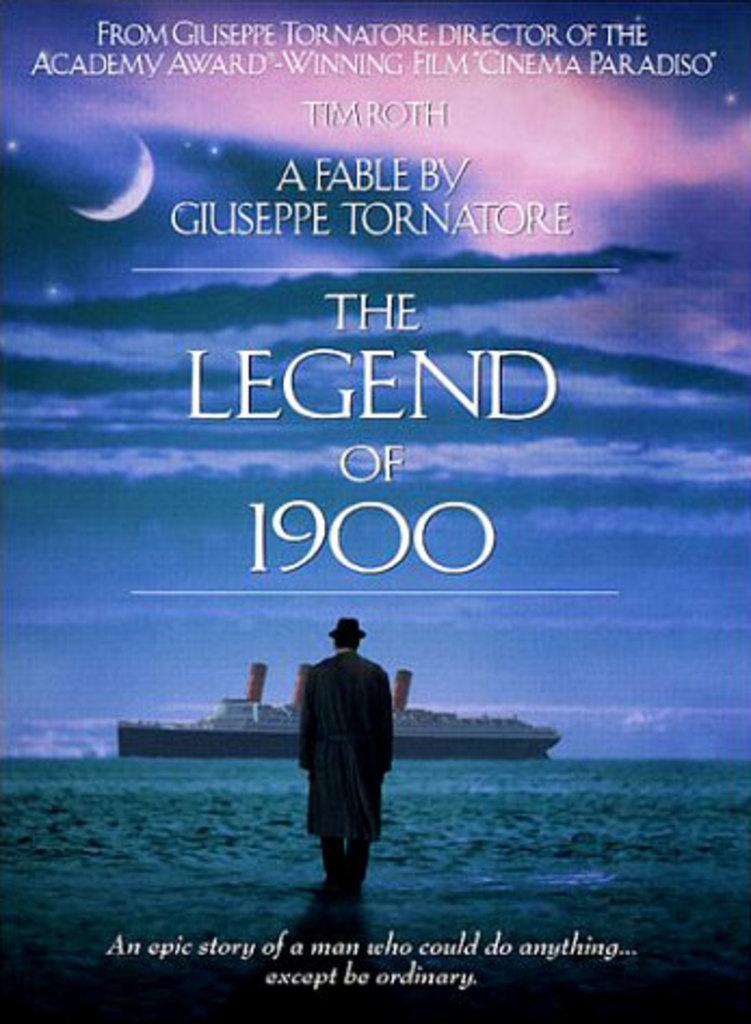What type of visual is depicted in the image? The image is a poster. Who or what is featured in the poster? There is a man in the poster. What is the man doing or interacting with in the poster? There is a boat in the poster, which suggests that the man might be associated with the boat. What can be seen at the bottom of the poster? There is water at the bottom of the poster. What is visible at the top of the poster? There is sky at the top of the poster. What type of linen is draped over the back of the boat in the image? There is no linen present in the image, nor is there any indication of a draped fabric over the back of the boat. 